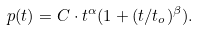Convert formula to latex. <formula><loc_0><loc_0><loc_500><loc_500>p ( t ) = C \cdot t ^ { \alpha } ( 1 + ( t / t _ { o } ) ^ { \beta } ) .</formula> 